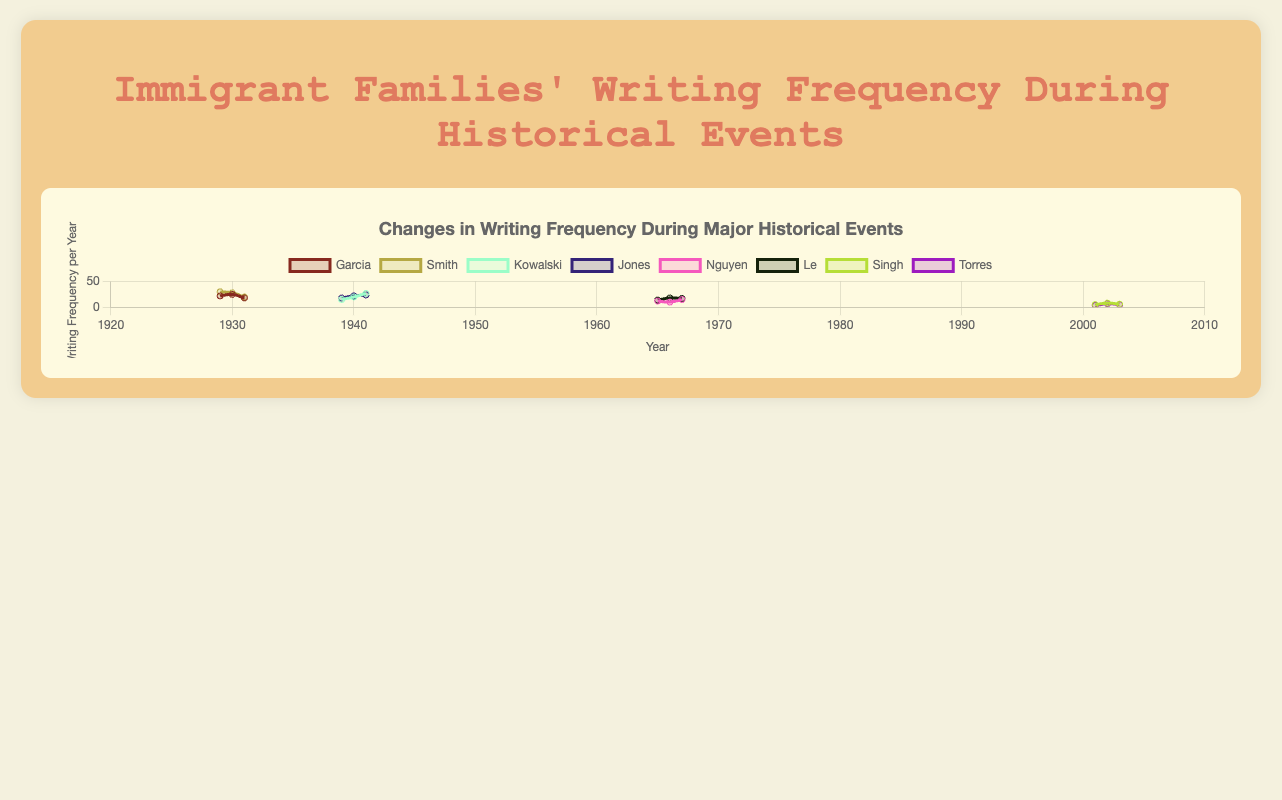Which family had the highest writing frequency during the Great Depression? Look for the highest point in the "Great Depression" period on the plot. The highest writing frequency is marked for the Smith family in 1929 with a value of 30.
Answer: Smith How did the writing frequency change for the Kowalski family during World War II? Analyze the curve for the Kowalski family during the years 1939-1941. The frequency increased from 15 in 1939 to 20 in 1940, and further to 27 in 1941.
Answer: Increased Which event had the lowest average writing frequency, and what was it? Calculate the average for each event. For "9/11 Attacks", Singh and Torres had frequencies of 5, 8, 6, 3, 7, and 5. The average is (5+8+6+3+7+5)/6 = 34/6 ≈ 5.67, which is less compared to other events.
Answer: 9/11 Attacks, 5.67 Compare the frequency trend between the Nguyen and Le families during the Vietnam War. Both families have similar trends, starting lower, peaking in the second year, and then slightly decreasing. Specifically for Nguyen: 12, 10, 15, and for Le: 14, 18, 17.
Answer: Similar trend Which family showed the most significant change in writing frequency during a single event? Calculate the differences for each family across their respective events. The Smith family during the Great Depression had a change from 30 to 20, which is a significant difference of 10.
Answer: Smith During the 9/11 Attacks, which family had a more stable writing frequency? Examine the frequency values for Singh (5, 8, 6) and Torres (3, 7, 5). Torres has a slight drop and rise, whereas Singh shows smaller fluctuations.
Answer: Singh What is the total writing frequency for the Garcia family during the Great Depression? Sum the values for Garcia during 1929-1931: 22 + 25 + 18 = 65.
Answer: 65 Which year had the highest cumulative writing frequency across all families, and what was the total? Aggregate the yearly frequencies across all families. For 1941, Kowalski (27) and Jones (24) sum up to 51, which is the highest cumulative value.
Answer: 1941, 51 Compare the final year writing frequencies of families experiencing the Great Depression and World War II. For the final year 1931 (Great Depression), Garcia (18) and Smith (20). For the final year 1941 (World War II), Kowalski (27) and Jones (24). The sum for World War II (51) is higher than for the Great Depression (38).
Answer: World War II (51) What is the change in writing frequency for the Nguyen family from the first to the third year of the Vietnam War? Look at the frequencies for the years 1965 and 1967 for Nguyen, 12 in 1965 and 15 in 1967. The change is 15 - 12 = 3.
Answer: 3 